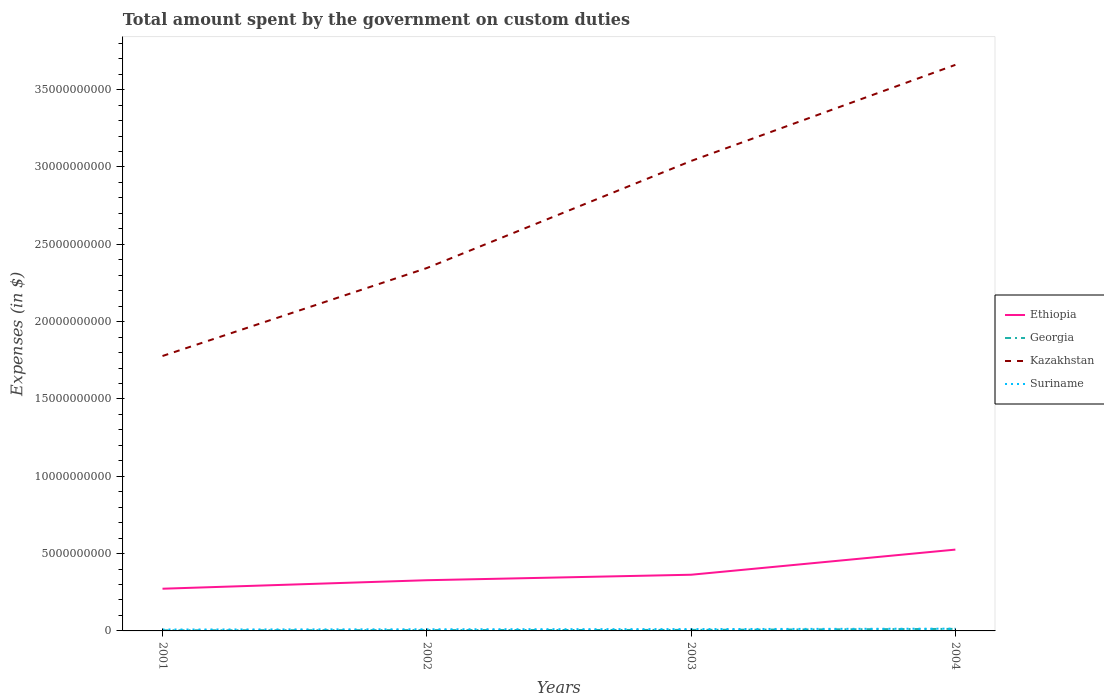Does the line corresponding to Kazakhstan intersect with the line corresponding to Georgia?
Your answer should be compact. No. Across all years, what is the maximum amount spent on custom duties by the government in Ethiopia?
Provide a short and direct response. 2.73e+09. In which year was the amount spent on custom duties by the government in Ethiopia maximum?
Your answer should be compact. 2001. What is the total amount spent on custom duties by the government in Georgia in the graph?
Offer a terse response. -9.33e+07. What is the difference between the highest and the second highest amount spent on custom duties by the government in Suriname?
Make the answer very short. 5.53e+07. What is the difference between the highest and the lowest amount spent on custom duties by the government in Georgia?
Offer a very short reply. 1. Is the amount spent on custom duties by the government in Ethiopia strictly greater than the amount spent on custom duties by the government in Suriname over the years?
Ensure brevity in your answer.  No. Are the values on the major ticks of Y-axis written in scientific E-notation?
Provide a succinct answer. No. Does the graph contain grids?
Provide a succinct answer. No. Where does the legend appear in the graph?
Offer a terse response. Center right. What is the title of the graph?
Your answer should be very brief. Total amount spent by the government on custom duties. What is the label or title of the Y-axis?
Provide a short and direct response. Expenses (in $). What is the Expenses (in $) in Ethiopia in 2001?
Your answer should be very brief. 2.73e+09. What is the Expenses (in $) of Georgia in 2001?
Your response must be concise. 3.85e+07. What is the Expenses (in $) in Kazakhstan in 2001?
Give a very brief answer. 1.78e+1. What is the Expenses (in $) in Suriname in 2001?
Your answer should be very brief. 9.11e+07. What is the Expenses (in $) in Ethiopia in 2002?
Your response must be concise. 3.28e+09. What is the Expenses (in $) of Georgia in 2002?
Offer a terse response. 5.09e+07. What is the Expenses (in $) of Kazakhstan in 2002?
Your answer should be very brief. 2.35e+1. What is the Expenses (in $) of Suriname in 2002?
Your answer should be compact. 1.07e+08. What is the Expenses (in $) of Ethiopia in 2003?
Make the answer very short. 3.63e+09. What is the Expenses (in $) in Georgia in 2003?
Offer a very short reply. 6.63e+07. What is the Expenses (in $) of Kazakhstan in 2003?
Offer a terse response. 3.04e+1. What is the Expenses (in $) of Suriname in 2003?
Keep it short and to the point. 1.19e+08. What is the Expenses (in $) of Ethiopia in 2004?
Your response must be concise. 5.26e+09. What is the Expenses (in $) in Georgia in 2004?
Provide a succinct answer. 1.32e+08. What is the Expenses (in $) of Kazakhstan in 2004?
Make the answer very short. 3.66e+1. What is the Expenses (in $) of Suriname in 2004?
Your answer should be very brief. 1.46e+08. Across all years, what is the maximum Expenses (in $) of Ethiopia?
Provide a short and direct response. 5.26e+09. Across all years, what is the maximum Expenses (in $) of Georgia?
Your answer should be very brief. 1.32e+08. Across all years, what is the maximum Expenses (in $) in Kazakhstan?
Provide a short and direct response. 3.66e+1. Across all years, what is the maximum Expenses (in $) of Suriname?
Your answer should be compact. 1.46e+08. Across all years, what is the minimum Expenses (in $) in Ethiopia?
Offer a very short reply. 2.73e+09. Across all years, what is the minimum Expenses (in $) in Georgia?
Provide a short and direct response. 3.85e+07. Across all years, what is the minimum Expenses (in $) in Kazakhstan?
Offer a very short reply. 1.78e+1. Across all years, what is the minimum Expenses (in $) in Suriname?
Ensure brevity in your answer.  9.11e+07. What is the total Expenses (in $) of Ethiopia in the graph?
Your response must be concise. 1.49e+1. What is the total Expenses (in $) in Georgia in the graph?
Provide a short and direct response. 2.88e+08. What is the total Expenses (in $) in Kazakhstan in the graph?
Keep it short and to the point. 1.08e+11. What is the total Expenses (in $) in Suriname in the graph?
Provide a succinct answer. 4.63e+08. What is the difference between the Expenses (in $) in Ethiopia in 2001 and that in 2002?
Keep it short and to the point. -5.50e+08. What is the difference between the Expenses (in $) of Georgia in 2001 and that in 2002?
Your answer should be very brief. -1.24e+07. What is the difference between the Expenses (in $) of Kazakhstan in 2001 and that in 2002?
Keep it short and to the point. -5.69e+09. What is the difference between the Expenses (in $) in Suriname in 2001 and that in 2002?
Give a very brief answer. -1.61e+07. What is the difference between the Expenses (in $) in Ethiopia in 2001 and that in 2003?
Your answer should be compact. -9.04e+08. What is the difference between the Expenses (in $) of Georgia in 2001 and that in 2003?
Keep it short and to the point. -2.78e+07. What is the difference between the Expenses (in $) of Kazakhstan in 2001 and that in 2003?
Your answer should be very brief. -1.26e+1. What is the difference between the Expenses (in $) of Suriname in 2001 and that in 2003?
Give a very brief answer. -2.77e+07. What is the difference between the Expenses (in $) in Ethiopia in 2001 and that in 2004?
Offer a terse response. -2.53e+09. What is the difference between the Expenses (in $) in Georgia in 2001 and that in 2004?
Provide a succinct answer. -9.33e+07. What is the difference between the Expenses (in $) of Kazakhstan in 2001 and that in 2004?
Your answer should be compact. -1.88e+1. What is the difference between the Expenses (in $) in Suriname in 2001 and that in 2004?
Ensure brevity in your answer.  -5.53e+07. What is the difference between the Expenses (in $) of Ethiopia in 2002 and that in 2003?
Your answer should be very brief. -3.55e+08. What is the difference between the Expenses (in $) of Georgia in 2002 and that in 2003?
Your response must be concise. -1.54e+07. What is the difference between the Expenses (in $) of Kazakhstan in 2002 and that in 2003?
Offer a terse response. -6.92e+09. What is the difference between the Expenses (in $) in Suriname in 2002 and that in 2003?
Your answer should be very brief. -1.16e+07. What is the difference between the Expenses (in $) in Ethiopia in 2002 and that in 2004?
Ensure brevity in your answer.  -1.98e+09. What is the difference between the Expenses (in $) of Georgia in 2002 and that in 2004?
Provide a short and direct response. -8.09e+07. What is the difference between the Expenses (in $) in Kazakhstan in 2002 and that in 2004?
Your response must be concise. -1.31e+1. What is the difference between the Expenses (in $) of Suriname in 2002 and that in 2004?
Ensure brevity in your answer.  -3.92e+07. What is the difference between the Expenses (in $) of Ethiopia in 2003 and that in 2004?
Provide a succinct answer. -1.63e+09. What is the difference between the Expenses (in $) of Georgia in 2003 and that in 2004?
Offer a very short reply. -6.55e+07. What is the difference between the Expenses (in $) of Kazakhstan in 2003 and that in 2004?
Your response must be concise. -6.22e+09. What is the difference between the Expenses (in $) of Suriname in 2003 and that in 2004?
Offer a very short reply. -2.77e+07. What is the difference between the Expenses (in $) of Ethiopia in 2001 and the Expenses (in $) of Georgia in 2002?
Ensure brevity in your answer.  2.68e+09. What is the difference between the Expenses (in $) of Ethiopia in 2001 and the Expenses (in $) of Kazakhstan in 2002?
Keep it short and to the point. -2.07e+1. What is the difference between the Expenses (in $) of Ethiopia in 2001 and the Expenses (in $) of Suriname in 2002?
Make the answer very short. 2.62e+09. What is the difference between the Expenses (in $) in Georgia in 2001 and the Expenses (in $) in Kazakhstan in 2002?
Your answer should be compact. -2.34e+1. What is the difference between the Expenses (in $) in Georgia in 2001 and the Expenses (in $) in Suriname in 2002?
Your answer should be very brief. -6.87e+07. What is the difference between the Expenses (in $) of Kazakhstan in 2001 and the Expenses (in $) of Suriname in 2002?
Your answer should be very brief. 1.77e+1. What is the difference between the Expenses (in $) in Ethiopia in 2001 and the Expenses (in $) in Georgia in 2003?
Keep it short and to the point. 2.66e+09. What is the difference between the Expenses (in $) of Ethiopia in 2001 and the Expenses (in $) of Kazakhstan in 2003?
Offer a very short reply. -2.77e+1. What is the difference between the Expenses (in $) of Ethiopia in 2001 and the Expenses (in $) of Suriname in 2003?
Provide a succinct answer. 2.61e+09. What is the difference between the Expenses (in $) in Georgia in 2001 and the Expenses (in $) in Kazakhstan in 2003?
Your response must be concise. -3.03e+1. What is the difference between the Expenses (in $) in Georgia in 2001 and the Expenses (in $) in Suriname in 2003?
Your answer should be very brief. -8.02e+07. What is the difference between the Expenses (in $) of Kazakhstan in 2001 and the Expenses (in $) of Suriname in 2003?
Your answer should be very brief. 1.77e+1. What is the difference between the Expenses (in $) in Ethiopia in 2001 and the Expenses (in $) in Georgia in 2004?
Offer a terse response. 2.60e+09. What is the difference between the Expenses (in $) in Ethiopia in 2001 and the Expenses (in $) in Kazakhstan in 2004?
Provide a short and direct response. -3.39e+1. What is the difference between the Expenses (in $) of Ethiopia in 2001 and the Expenses (in $) of Suriname in 2004?
Your answer should be compact. 2.58e+09. What is the difference between the Expenses (in $) in Georgia in 2001 and the Expenses (in $) in Kazakhstan in 2004?
Provide a short and direct response. -3.66e+1. What is the difference between the Expenses (in $) of Georgia in 2001 and the Expenses (in $) of Suriname in 2004?
Provide a succinct answer. -1.08e+08. What is the difference between the Expenses (in $) of Kazakhstan in 2001 and the Expenses (in $) of Suriname in 2004?
Give a very brief answer. 1.76e+1. What is the difference between the Expenses (in $) in Ethiopia in 2002 and the Expenses (in $) in Georgia in 2003?
Give a very brief answer. 3.21e+09. What is the difference between the Expenses (in $) of Ethiopia in 2002 and the Expenses (in $) of Kazakhstan in 2003?
Give a very brief answer. -2.71e+1. What is the difference between the Expenses (in $) in Ethiopia in 2002 and the Expenses (in $) in Suriname in 2003?
Provide a succinct answer. 3.16e+09. What is the difference between the Expenses (in $) in Georgia in 2002 and the Expenses (in $) in Kazakhstan in 2003?
Ensure brevity in your answer.  -3.03e+1. What is the difference between the Expenses (in $) in Georgia in 2002 and the Expenses (in $) in Suriname in 2003?
Give a very brief answer. -6.78e+07. What is the difference between the Expenses (in $) in Kazakhstan in 2002 and the Expenses (in $) in Suriname in 2003?
Ensure brevity in your answer.  2.33e+1. What is the difference between the Expenses (in $) of Ethiopia in 2002 and the Expenses (in $) of Georgia in 2004?
Provide a succinct answer. 3.15e+09. What is the difference between the Expenses (in $) in Ethiopia in 2002 and the Expenses (in $) in Kazakhstan in 2004?
Your answer should be very brief. -3.33e+1. What is the difference between the Expenses (in $) in Ethiopia in 2002 and the Expenses (in $) in Suriname in 2004?
Keep it short and to the point. 3.13e+09. What is the difference between the Expenses (in $) in Georgia in 2002 and the Expenses (in $) in Kazakhstan in 2004?
Your answer should be very brief. -3.66e+1. What is the difference between the Expenses (in $) of Georgia in 2002 and the Expenses (in $) of Suriname in 2004?
Keep it short and to the point. -9.55e+07. What is the difference between the Expenses (in $) in Kazakhstan in 2002 and the Expenses (in $) in Suriname in 2004?
Offer a very short reply. 2.33e+1. What is the difference between the Expenses (in $) in Ethiopia in 2003 and the Expenses (in $) in Georgia in 2004?
Keep it short and to the point. 3.50e+09. What is the difference between the Expenses (in $) in Ethiopia in 2003 and the Expenses (in $) in Kazakhstan in 2004?
Offer a terse response. -3.30e+1. What is the difference between the Expenses (in $) of Ethiopia in 2003 and the Expenses (in $) of Suriname in 2004?
Your answer should be very brief. 3.49e+09. What is the difference between the Expenses (in $) of Georgia in 2003 and the Expenses (in $) of Kazakhstan in 2004?
Provide a succinct answer. -3.65e+1. What is the difference between the Expenses (in $) of Georgia in 2003 and the Expenses (in $) of Suriname in 2004?
Provide a short and direct response. -8.01e+07. What is the difference between the Expenses (in $) of Kazakhstan in 2003 and the Expenses (in $) of Suriname in 2004?
Your answer should be compact. 3.02e+1. What is the average Expenses (in $) in Ethiopia per year?
Keep it short and to the point. 3.72e+09. What is the average Expenses (in $) of Georgia per year?
Your answer should be very brief. 7.19e+07. What is the average Expenses (in $) in Kazakhstan per year?
Your answer should be compact. 2.71e+1. What is the average Expenses (in $) of Suriname per year?
Give a very brief answer. 1.16e+08. In the year 2001, what is the difference between the Expenses (in $) in Ethiopia and Expenses (in $) in Georgia?
Give a very brief answer. 2.69e+09. In the year 2001, what is the difference between the Expenses (in $) in Ethiopia and Expenses (in $) in Kazakhstan?
Make the answer very short. -1.50e+1. In the year 2001, what is the difference between the Expenses (in $) of Ethiopia and Expenses (in $) of Suriname?
Your response must be concise. 2.64e+09. In the year 2001, what is the difference between the Expenses (in $) of Georgia and Expenses (in $) of Kazakhstan?
Your response must be concise. -1.77e+1. In the year 2001, what is the difference between the Expenses (in $) of Georgia and Expenses (in $) of Suriname?
Your answer should be very brief. -5.26e+07. In the year 2001, what is the difference between the Expenses (in $) in Kazakhstan and Expenses (in $) in Suriname?
Ensure brevity in your answer.  1.77e+1. In the year 2002, what is the difference between the Expenses (in $) in Ethiopia and Expenses (in $) in Georgia?
Your answer should be compact. 3.23e+09. In the year 2002, what is the difference between the Expenses (in $) in Ethiopia and Expenses (in $) in Kazakhstan?
Your response must be concise. -2.02e+1. In the year 2002, what is the difference between the Expenses (in $) of Ethiopia and Expenses (in $) of Suriname?
Your answer should be compact. 3.17e+09. In the year 2002, what is the difference between the Expenses (in $) of Georgia and Expenses (in $) of Kazakhstan?
Ensure brevity in your answer.  -2.34e+1. In the year 2002, what is the difference between the Expenses (in $) in Georgia and Expenses (in $) in Suriname?
Your answer should be very brief. -5.63e+07. In the year 2002, what is the difference between the Expenses (in $) in Kazakhstan and Expenses (in $) in Suriname?
Your response must be concise. 2.34e+1. In the year 2003, what is the difference between the Expenses (in $) in Ethiopia and Expenses (in $) in Georgia?
Keep it short and to the point. 3.57e+09. In the year 2003, what is the difference between the Expenses (in $) of Ethiopia and Expenses (in $) of Kazakhstan?
Ensure brevity in your answer.  -2.68e+1. In the year 2003, what is the difference between the Expenses (in $) of Ethiopia and Expenses (in $) of Suriname?
Provide a succinct answer. 3.51e+09. In the year 2003, what is the difference between the Expenses (in $) of Georgia and Expenses (in $) of Kazakhstan?
Your response must be concise. -3.03e+1. In the year 2003, what is the difference between the Expenses (in $) of Georgia and Expenses (in $) of Suriname?
Provide a succinct answer. -5.24e+07. In the year 2003, what is the difference between the Expenses (in $) in Kazakhstan and Expenses (in $) in Suriname?
Provide a short and direct response. 3.03e+1. In the year 2004, what is the difference between the Expenses (in $) of Ethiopia and Expenses (in $) of Georgia?
Provide a succinct answer. 5.13e+09. In the year 2004, what is the difference between the Expenses (in $) of Ethiopia and Expenses (in $) of Kazakhstan?
Give a very brief answer. -3.13e+1. In the year 2004, what is the difference between the Expenses (in $) in Ethiopia and Expenses (in $) in Suriname?
Your answer should be very brief. 5.11e+09. In the year 2004, what is the difference between the Expenses (in $) in Georgia and Expenses (in $) in Kazakhstan?
Make the answer very short. -3.65e+1. In the year 2004, what is the difference between the Expenses (in $) of Georgia and Expenses (in $) of Suriname?
Ensure brevity in your answer.  -1.46e+07. In the year 2004, what is the difference between the Expenses (in $) in Kazakhstan and Expenses (in $) in Suriname?
Offer a terse response. 3.65e+1. What is the ratio of the Expenses (in $) of Ethiopia in 2001 to that in 2002?
Make the answer very short. 0.83. What is the ratio of the Expenses (in $) of Georgia in 2001 to that in 2002?
Your answer should be compact. 0.76. What is the ratio of the Expenses (in $) of Kazakhstan in 2001 to that in 2002?
Provide a short and direct response. 0.76. What is the ratio of the Expenses (in $) of Suriname in 2001 to that in 2002?
Provide a succinct answer. 0.85. What is the ratio of the Expenses (in $) of Ethiopia in 2001 to that in 2003?
Keep it short and to the point. 0.75. What is the ratio of the Expenses (in $) of Georgia in 2001 to that in 2003?
Your answer should be very brief. 0.58. What is the ratio of the Expenses (in $) in Kazakhstan in 2001 to that in 2003?
Provide a short and direct response. 0.58. What is the ratio of the Expenses (in $) in Suriname in 2001 to that in 2003?
Your answer should be compact. 0.77. What is the ratio of the Expenses (in $) in Ethiopia in 2001 to that in 2004?
Offer a terse response. 0.52. What is the ratio of the Expenses (in $) of Georgia in 2001 to that in 2004?
Provide a succinct answer. 0.29. What is the ratio of the Expenses (in $) of Kazakhstan in 2001 to that in 2004?
Provide a succinct answer. 0.49. What is the ratio of the Expenses (in $) of Suriname in 2001 to that in 2004?
Your answer should be compact. 0.62. What is the ratio of the Expenses (in $) in Ethiopia in 2002 to that in 2003?
Offer a terse response. 0.9. What is the ratio of the Expenses (in $) in Georgia in 2002 to that in 2003?
Your answer should be compact. 0.77. What is the ratio of the Expenses (in $) in Kazakhstan in 2002 to that in 2003?
Make the answer very short. 0.77. What is the ratio of the Expenses (in $) of Suriname in 2002 to that in 2003?
Keep it short and to the point. 0.9. What is the ratio of the Expenses (in $) of Ethiopia in 2002 to that in 2004?
Your answer should be compact. 0.62. What is the ratio of the Expenses (in $) in Georgia in 2002 to that in 2004?
Give a very brief answer. 0.39. What is the ratio of the Expenses (in $) in Kazakhstan in 2002 to that in 2004?
Your answer should be very brief. 0.64. What is the ratio of the Expenses (in $) of Suriname in 2002 to that in 2004?
Make the answer very short. 0.73. What is the ratio of the Expenses (in $) of Ethiopia in 2003 to that in 2004?
Offer a very short reply. 0.69. What is the ratio of the Expenses (in $) of Georgia in 2003 to that in 2004?
Give a very brief answer. 0.5. What is the ratio of the Expenses (in $) of Kazakhstan in 2003 to that in 2004?
Keep it short and to the point. 0.83. What is the ratio of the Expenses (in $) of Suriname in 2003 to that in 2004?
Provide a succinct answer. 0.81. What is the difference between the highest and the second highest Expenses (in $) in Ethiopia?
Provide a succinct answer. 1.63e+09. What is the difference between the highest and the second highest Expenses (in $) of Georgia?
Your answer should be compact. 6.55e+07. What is the difference between the highest and the second highest Expenses (in $) of Kazakhstan?
Offer a terse response. 6.22e+09. What is the difference between the highest and the second highest Expenses (in $) in Suriname?
Your response must be concise. 2.77e+07. What is the difference between the highest and the lowest Expenses (in $) of Ethiopia?
Provide a short and direct response. 2.53e+09. What is the difference between the highest and the lowest Expenses (in $) of Georgia?
Give a very brief answer. 9.33e+07. What is the difference between the highest and the lowest Expenses (in $) in Kazakhstan?
Make the answer very short. 1.88e+1. What is the difference between the highest and the lowest Expenses (in $) in Suriname?
Offer a very short reply. 5.53e+07. 